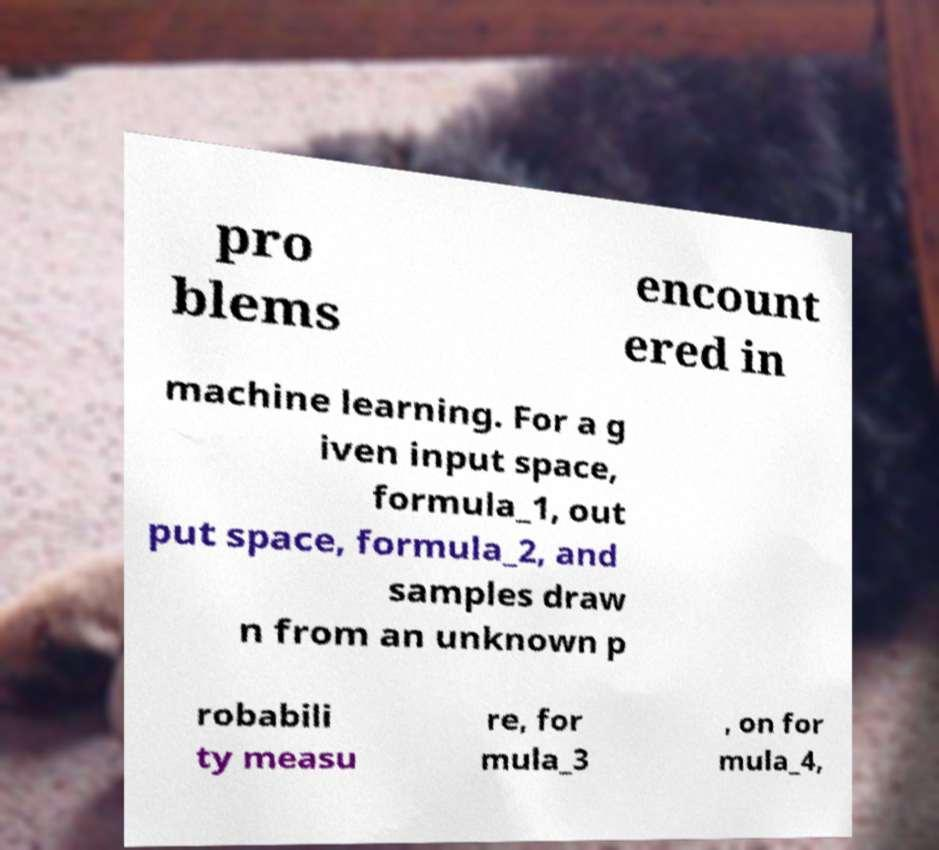There's text embedded in this image that I need extracted. Can you transcribe it verbatim? pro blems encount ered in machine learning. For a g iven input space, formula_1, out put space, formula_2, and samples draw n from an unknown p robabili ty measu re, for mula_3 , on for mula_4, 